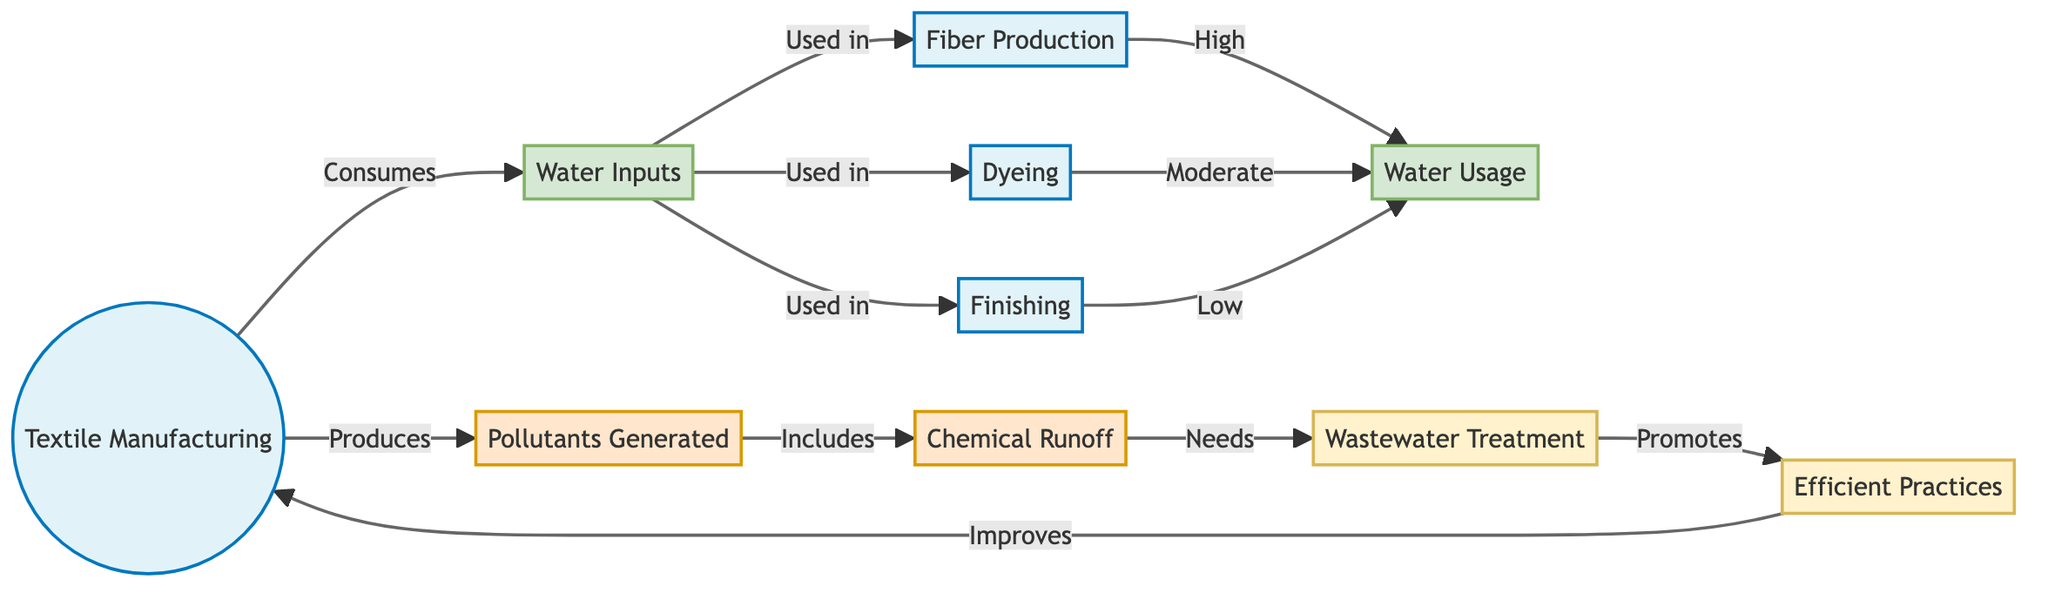What are the water inputs in textile manufacturing? The diagram indicates that the water inputs are associated with the textile manufacturing process. Specifically, they are represented as a direct input to the processes of fiber production, dyeing, and finishing.
Answer: Water Inputs What is produced by the textile manufacturing process? In the diagram, the output of the textile manufacturing process is shown as pollutants generated. These pollutants are the result of the processes that consume water.
Answer: Pollutants Generated Which process has the highest water usage? The diagram shows that among the three identified processes—fiber production, dyeing, and finishing—the fiber production process has a high water usage. This is indicated by the relationship linking fiber production to water usage labeled as "High".
Answer: High What type of treatment improves the textile manufacturing process? According to the diagram, "Efficient Practices" are shown as a treatment that improves the textile manufacturing process. This practice is promoted by wastewater treatment, which is necessary due to chemical runoff.
Answer: Efficient Practices How many processes are involved in textile manufacturing, as per the diagram? The diagram presents three main processes involved in textile manufacturing: fiber production, dyeing, and finishing, totaling three distinct processes.
Answer: Three What is necessary for chemical runoff as depicted in the diagram? The diagram specifies that chemical runoff necessitates wastewater treatment, indicating that a proper treatment process is vital to address the pollutants generated during manufacturing.
Answer: Wastewater Treatment What does wastewater treatment promote in the textile manufacturing process? According to the diagram, wastewater treatment promotes "Efficient Practices". This reciprocal relationship indicates that treating wastewater can lead to improvements in manufacturing efficiency.
Answer: Efficient Practices What is the relationship between dyeing and water usage? The diagram indicates that dyeing has a moderate water usage, which categorizes its consumption level between high and low in comparison to the fiber production and finishing processes, respectively.
Answer: Moderate What impacts the generation of pollutants in textile manufacturing? The diagram describes that the textile manufacturing process itself generates pollutants, with a specific reference to chemical runoff produced during this process. Thus, the relation directly indicates that manufacturing activities impact pollution levels.
Answer: Pollutants Generated 